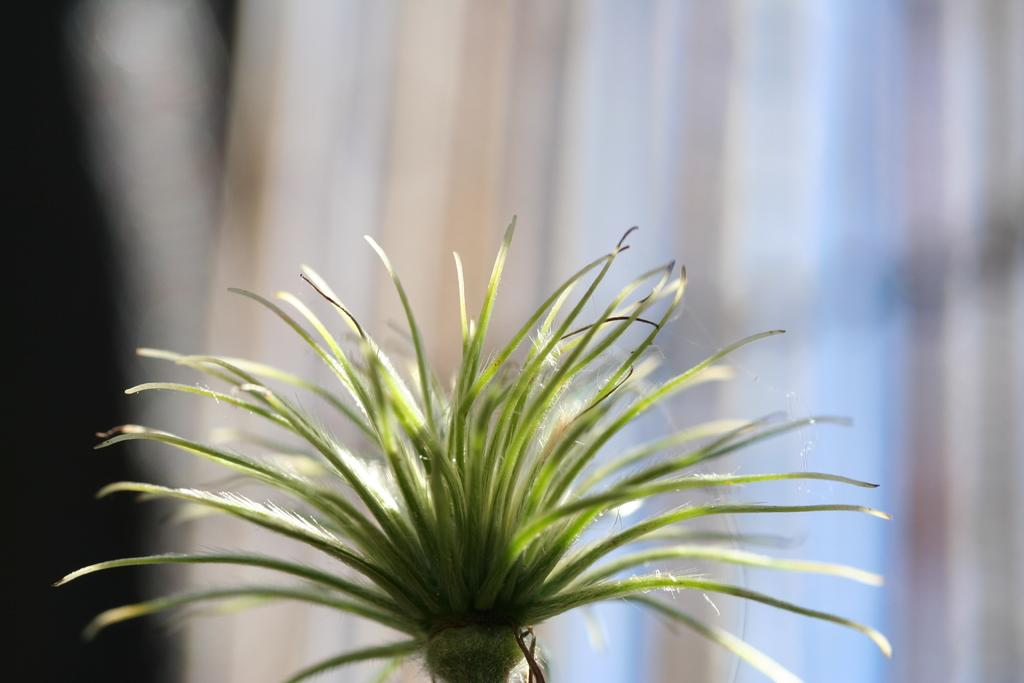What is present in the image? There is a plant in the image. Can you describe the background of the image? The background of the image is blurry. What type of cake is being served by the father in the image? There is no father or cake present in the image; it only features a plant and a blurry background. 